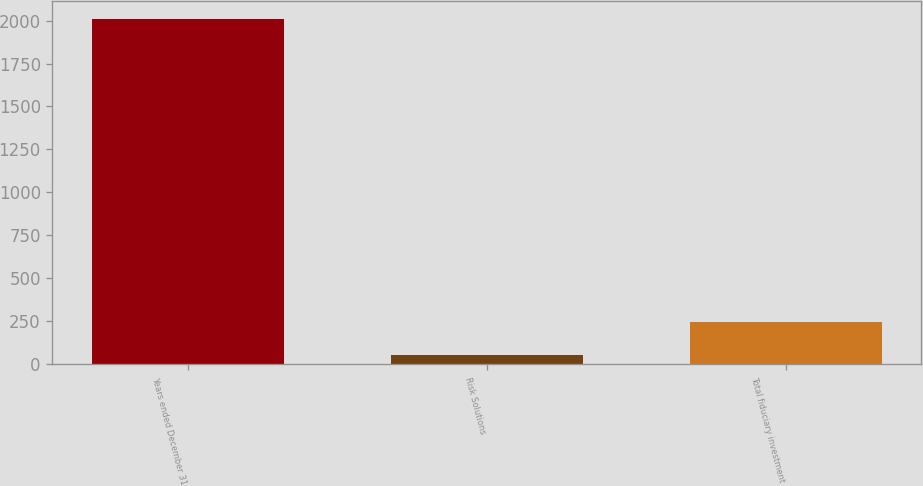<chart> <loc_0><loc_0><loc_500><loc_500><bar_chart><fcel>Years ended December 31<fcel>Risk Solutions<fcel>Total fiduciary investment<nl><fcel>2011<fcel>52<fcel>247.9<nl></chart> 